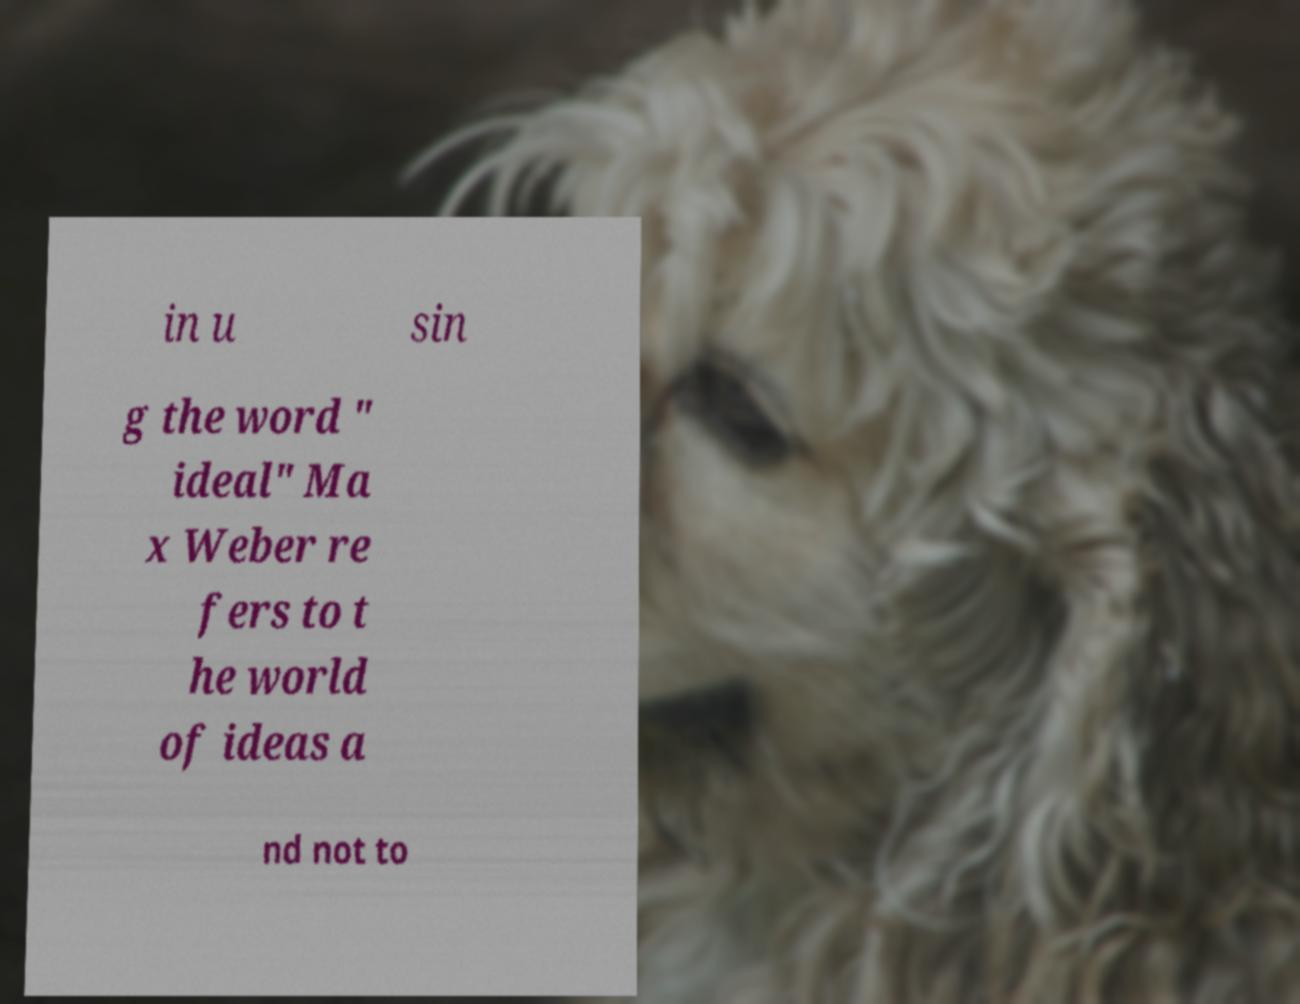I need the written content from this picture converted into text. Can you do that? in u sin g the word " ideal" Ma x Weber re fers to t he world of ideas a nd not to 